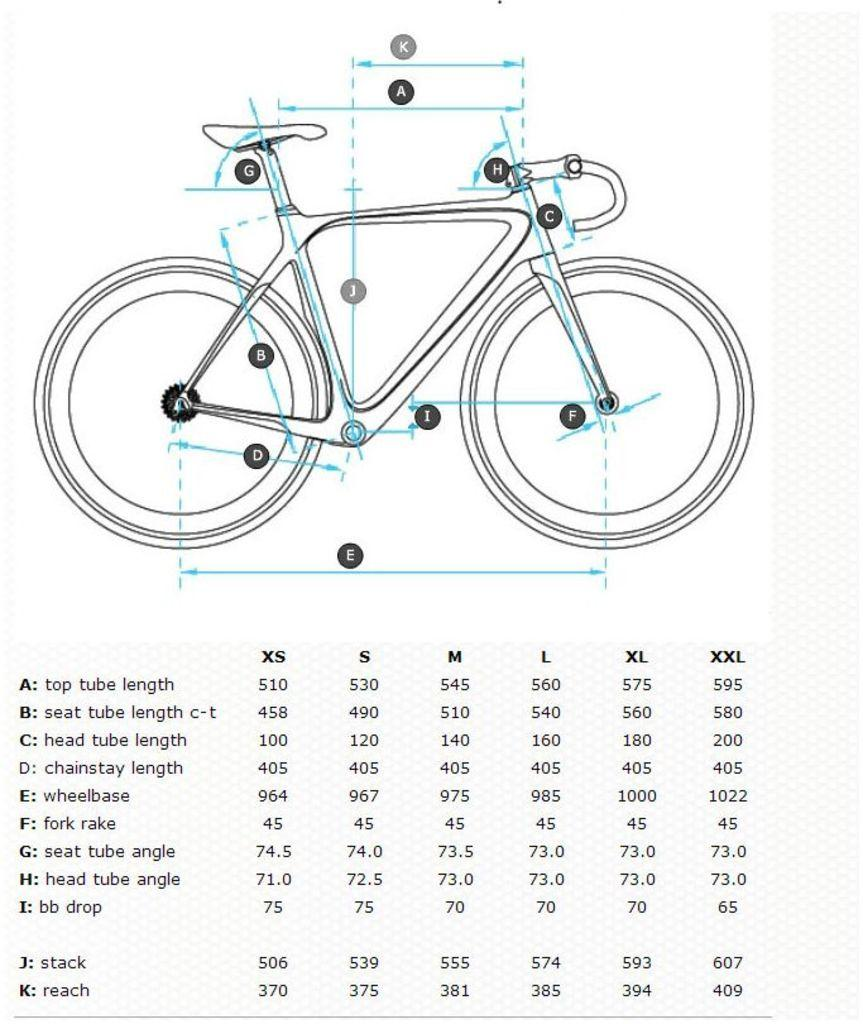<image>
Render a clear and concise summary of the photo. a line art graphic of a bicycle and it's length 